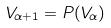Convert formula to latex. <formula><loc_0><loc_0><loc_500><loc_500>V _ { \alpha + 1 } = P ( V _ { \alpha } )</formula> 